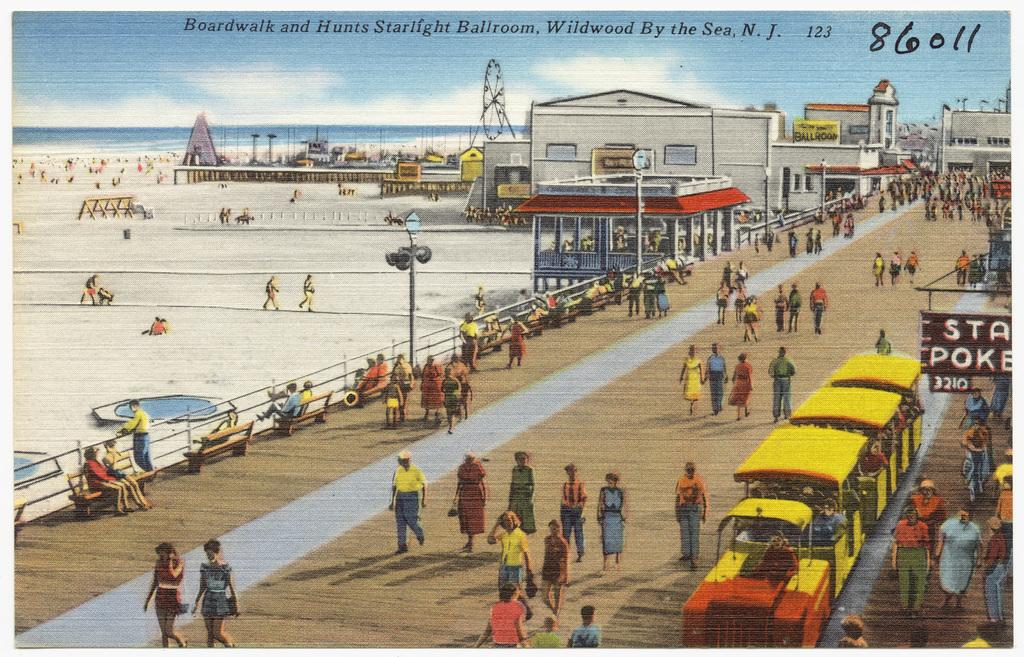<image>
Render a clear and concise summary of the photo. the boardwalk in NJ has many people on it 